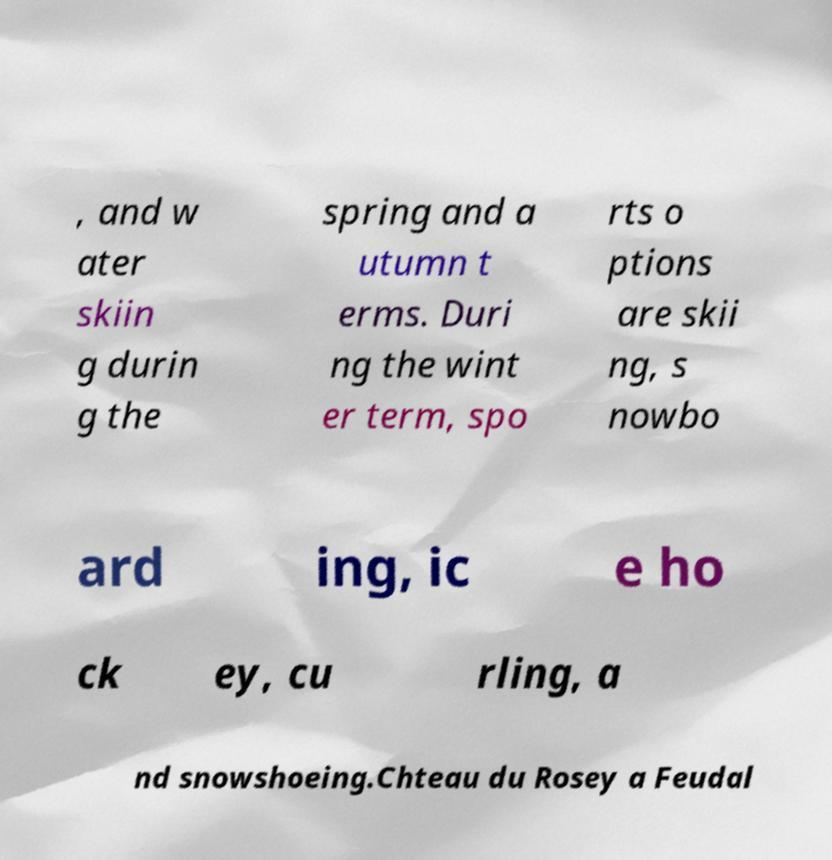Can you read and provide the text displayed in the image?This photo seems to have some interesting text. Can you extract and type it out for me? , and w ater skiin g durin g the spring and a utumn t erms. Duri ng the wint er term, spo rts o ptions are skii ng, s nowbo ard ing, ic e ho ck ey, cu rling, a nd snowshoeing.Chteau du Rosey a Feudal 